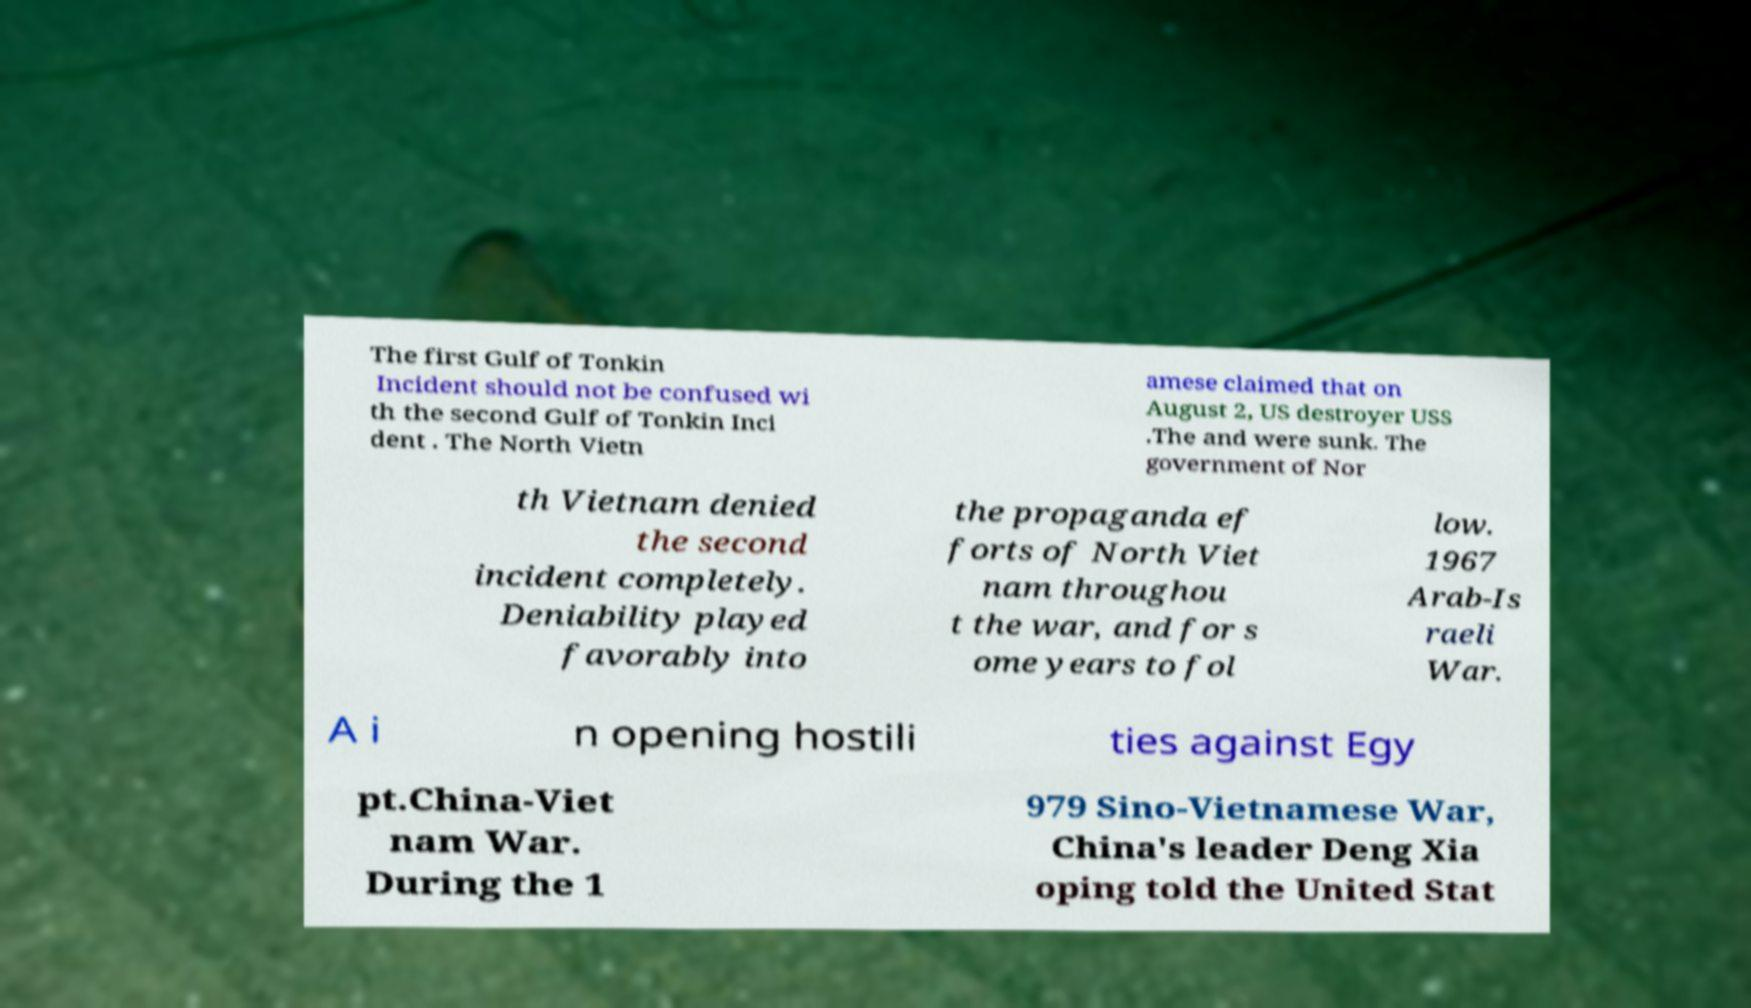Please read and relay the text visible in this image. What does it say? The first Gulf of Tonkin Incident should not be confused wi th the second Gulf of Tonkin Inci dent . The North Vietn amese claimed that on August 2, US destroyer USS .The and were sunk. The government of Nor th Vietnam denied the second incident completely. Deniability played favorably into the propaganda ef forts of North Viet nam throughou t the war, and for s ome years to fol low. 1967 Arab-Is raeli War. A i n opening hostili ties against Egy pt.China-Viet nam War. During the 1 979 Sino-Vietnamese War, China's leader Deng Xia oping told the United Stat 